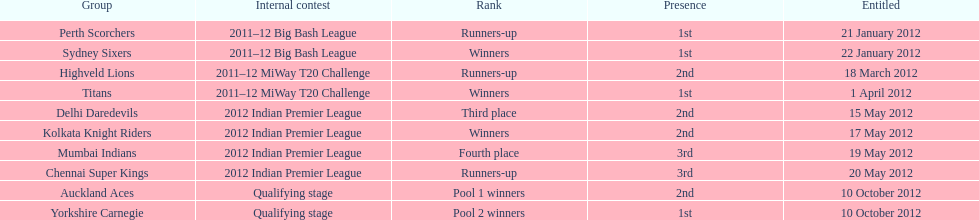Did the titans or the daredevils winners? Titans. 